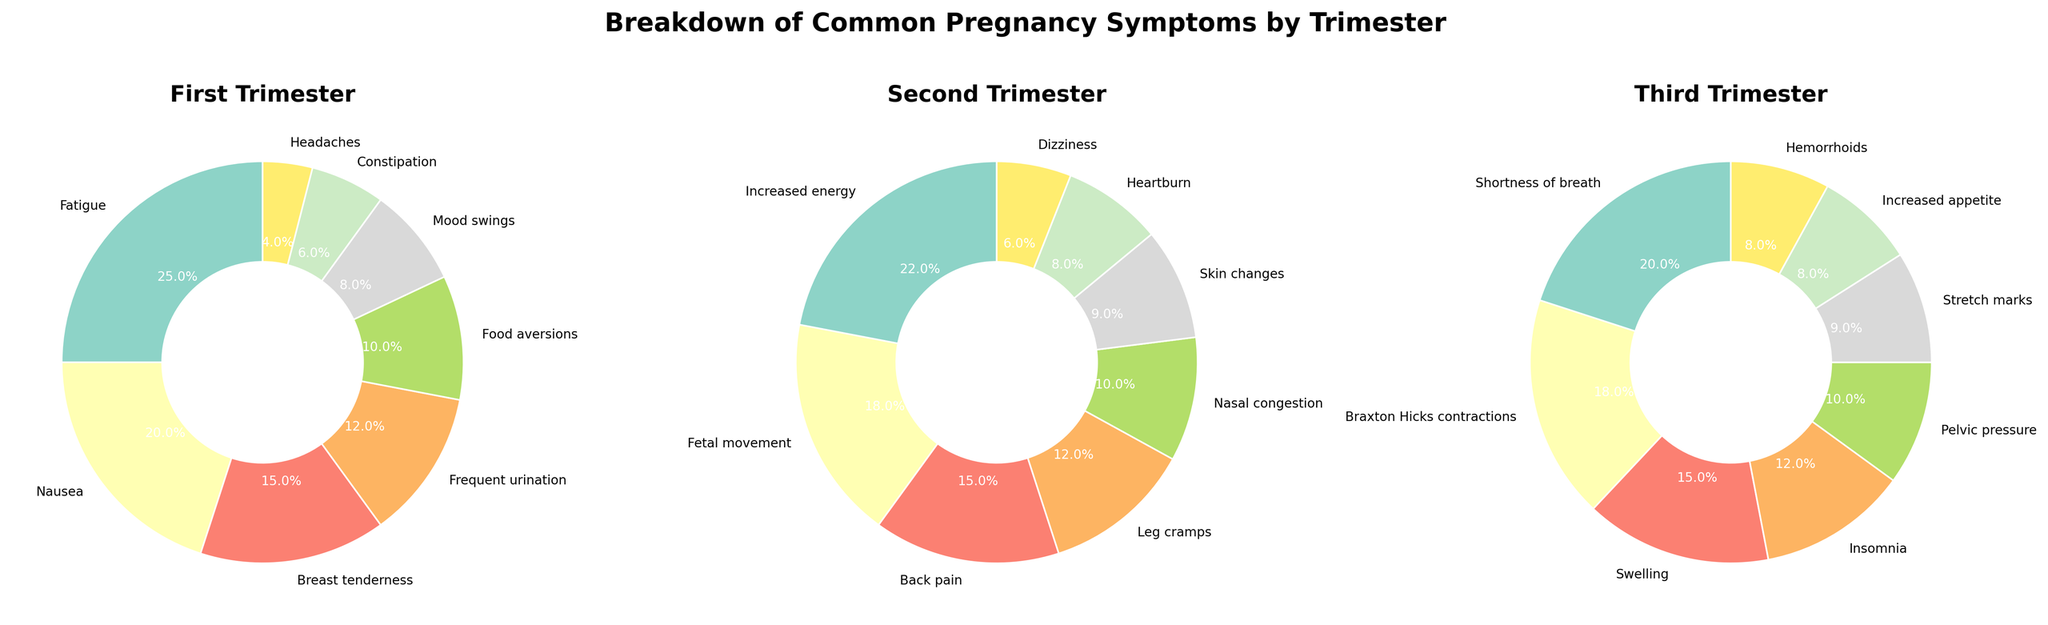What is the most common pregnancy symptom in the first trimester? The most common symptom in the first trimester is the one with the highest percentage. According to the figure, Fatigue accounts for 25%, which is the highest.
Answer: Fatigue Which trimester has a symptom related to increased energy, and what percentage does it represent? To find which trimester has increased energy, we look for "Increased energy" in the labels. It appears in the second trimester with a percentage of 22%.
Answer: Second, 22% How much higher is the percentage of back pain in the second trimester compared to leg cramps? Back pain is 15% and leg cramps are 12% in the second trimester. The difference is 15% - 12% = 3%.
Answer: 3% Which symptom appears in the third trimester with a percentage greater than or equal to 18%? In the third trimester, Shortness of breath (20%) and Braxton Hicks contractions (18%) both meet the criterion.
Answer: Shortness of breath, Braxton Hicks contractions What is the combined percentage of Nausea and Frequent urination in the first trimester? Nausea is 20% and Frequent urination is 12%. Their combined percentage is 20% + 12% = 32%.
Answer: 32% How many symptoms in the second trimester have a percentage less than 10%? The second trimester includes Nasal congestion (10%), Skin changes (9%), Heartburn (8%), and Dizziness (6%). Only Skin changes, Heartburn, and Dizziness are less than 10%, making it 3 symptoms.
Answer: 3 What is the visual difference between the wedges representing Food aversions and Mood swings in the first trimester? In the first trimester, visually, Food aversions and Mood swings can be compared based on wedge sizes. Food aversions (10%) has a slightly larger wedge than Mood swings (8%).
Answer: Food aversions wedge is larger Which trimesters feature swelling as a symptom, and what is the corresponding percentage? Swelling appears in the third trimester with a percentage of 15%. There are no mentions of swelling in the other trimesters.
Answer: Third, 15% Compare the percentage of symptoms labeled Breast tenderness in the first trimester to those of the symptoms labeled Stretch marks in the third trimester. Breast tenderness is 15% in the first trimester and Stretch marks is 9% in the third trimester. Comparing these, Breast tenderness has a higher percentage.
Answer: Breast tenderness is higher What is the total percentage of mood-related symptoms in the first trimester? Mood-related symptoms in the first trimester include Mood swings (8%). This is the only mood-related symptom present.
Answer: 8% 